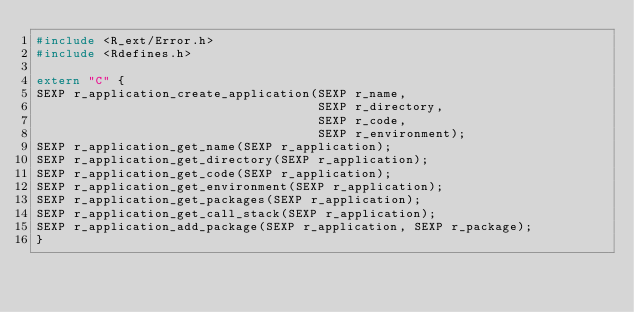<code> <loc_0><loc_0><loc_500><loc_500><_C_>#include <R_ext/Error.h>
#include <Rdefines.h>

extern "C" {
SEXP r_application_create_application(SEXP r_name,
                                      SEXP r_directory,
                                      SEXP r_code,
                                      SEXP r_environment);
SEXP r_application_get_name(SEXP r_application);
SEXP r_application_get_directory(SEXP r_application);
SEXP r_application_get_code(SEXP r_application);
SEXP r_application_get_environment(SEXP r_application);
SEXP r_application_get_packages(SEXP r_application);
SEXP r_application_get_call_stack(SEXP r_application);
SEXP r_application_add_package(SEXP r_application, SEXP r_package);
}
</code> 